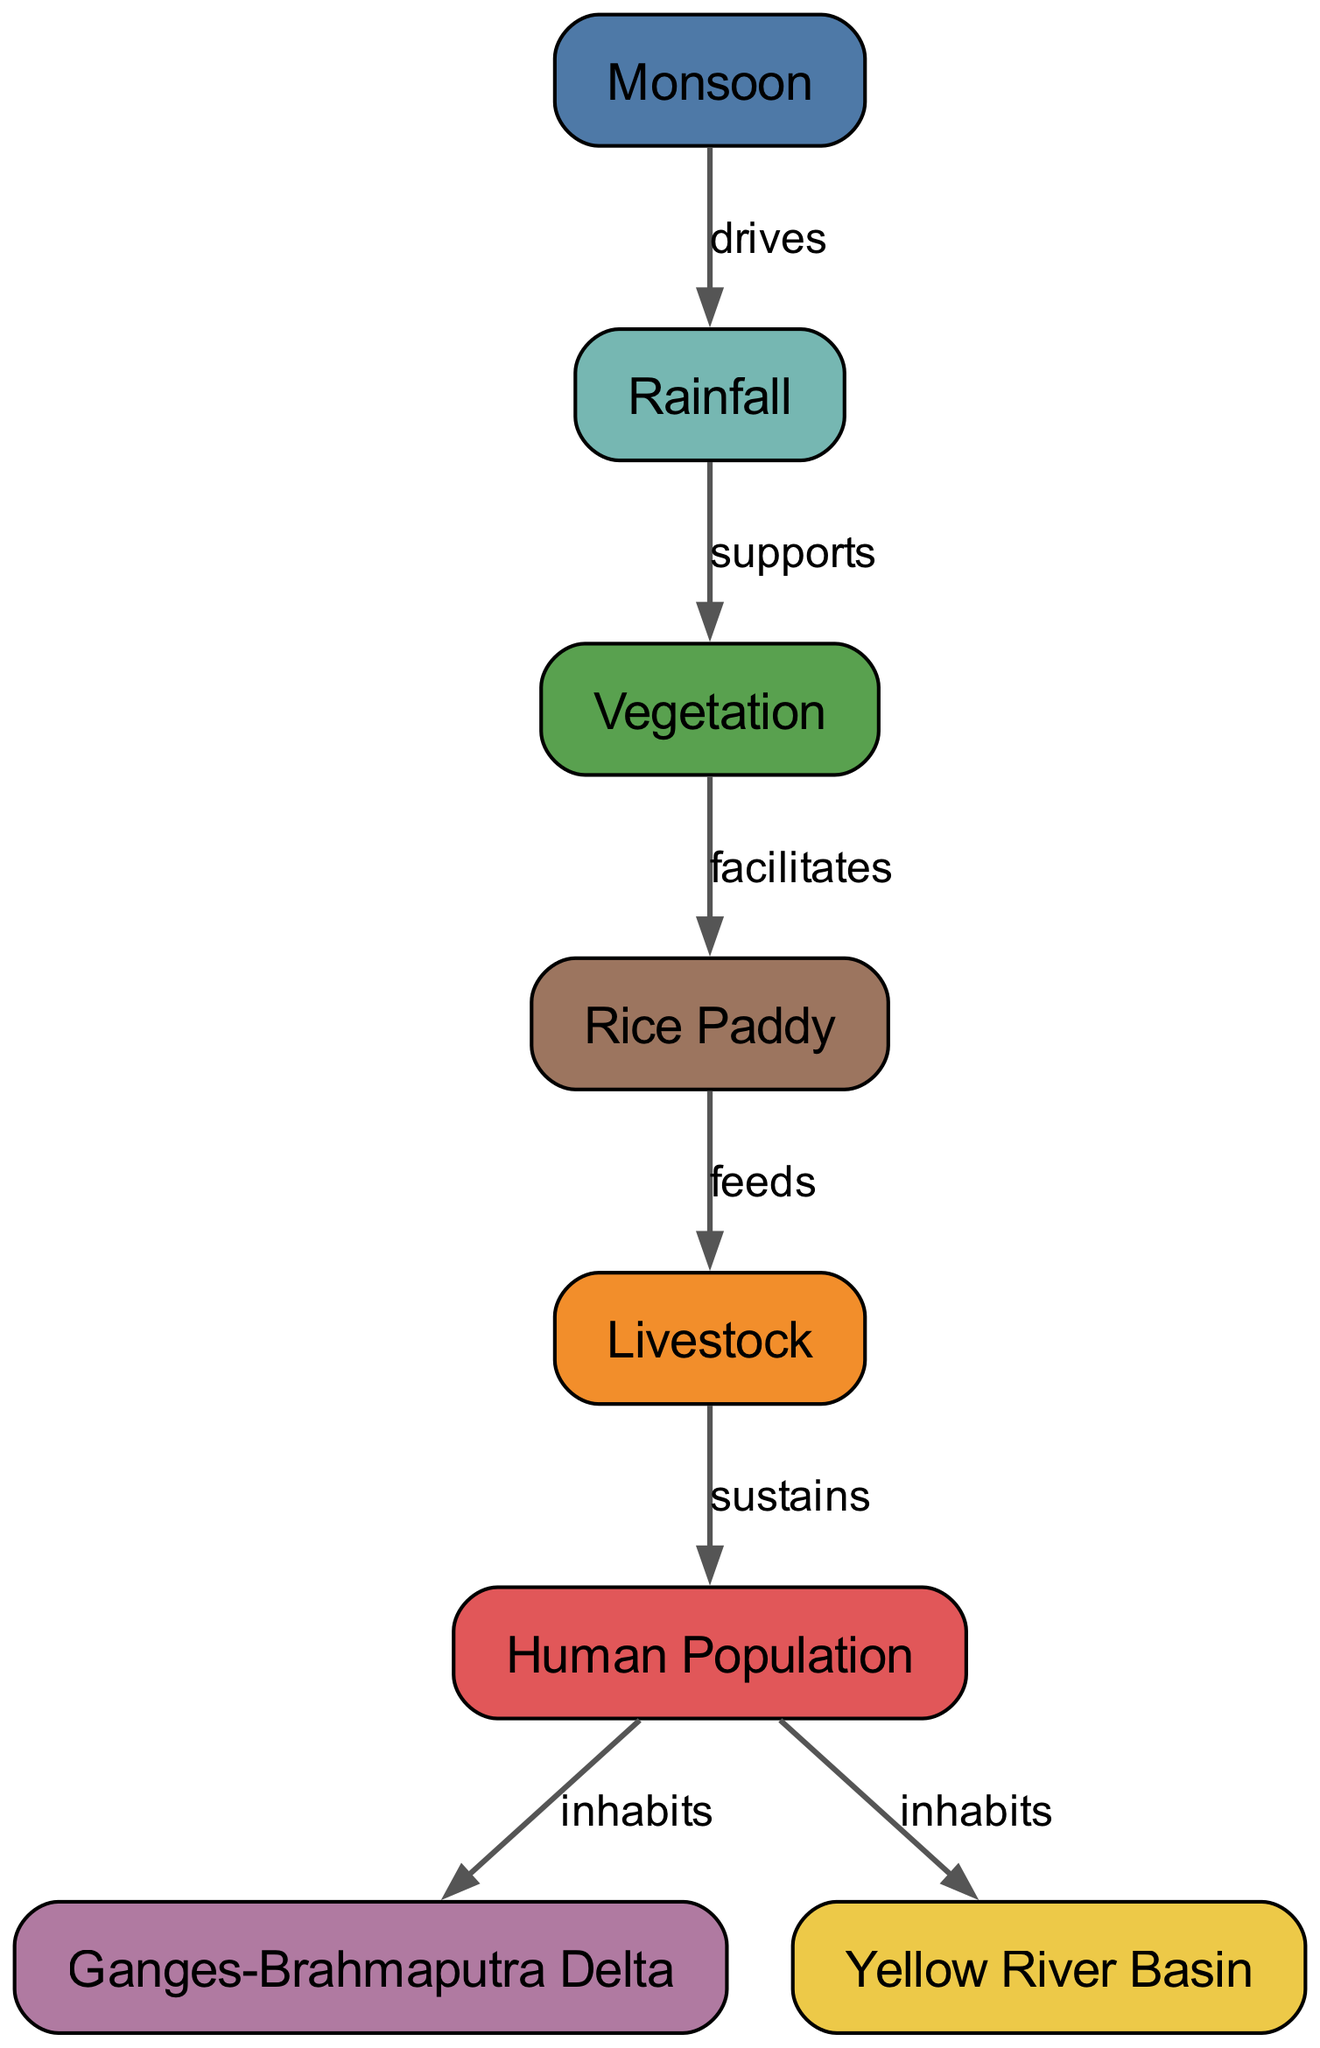What is the primary driver of rainfall in Southern Asia? The diagram shows a direct relationship labeled "drives" between the "Monsoon" node and the "Rainfall" node, indicating that the monsoon is the primary driver of rainfall in the region.
Answer: Monsoon How many nodes are present in the diagram? By counting all the distinct nodes listed in the data, the numbers of nodes such as monsoon, rainfall, vegetation, etc., total to eight, providing a clear outcome of the count from the diagram structure.
Answer: 8 What is the relationship between rainfall and vegetation? The relationship is defined in the diagram with the edge labeled "supports," indicating that rainfall supports the growth and health of vegetation.
Answer: Supports Which crop is primarily cultivated during the monsoon season? The node labeled "Rice Paddy" is specifically stated to be the primary crop cultivated during the monsoon season according to the diagram connections.
Answer: Rice Paddy What role does livestock play in the food chain? The diagram shows an edge labeled "feeds" connecting rice paddy to livestock, indicating that livestock are dependent on the rice paddies for food, thus explaining their role within the food chain.
Answer: Feeds Which regions are inhabited by the human population according to the diagram? The diagram has edges labeled "inhabits" connecting the "Human Population" node to both the "Ganges-Brahmaputra Delta" and "Yellow River Basin," showing that these regions are inhabited by the human population.
Answer: Ganges-Brahmaputra Delta, Yellow River Basin How does vegetation affect rice paddy? According to the diagram, there is a "facilitates" relationship between the "Vegetation" and "Rice Paddy" nodes, indicating that vegetation plays a crucial role in facilitating the growth of rice paddies.
Answer: Facilitates What sustains the human population in the diagram's context? The diagram indicates that livestock sustain the human population, evidenced by the "sustains" relationship connecting the "Livestock" node to the "Human Population" node.
Answer: Sustains 